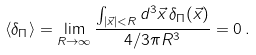Convert formula to latex. <formula><loc_0><loc_0><loc_500><loc_500>\langle \delta _ { \Pi } \rangle = \lim _ { R \rightarrow \infty } \frac { \int _ { | \vec { x } | < R } d ^ { 3 } \vec { x } \, \delta _ { \Pi } ( \vec { x } ) } { 4 / 3 \pi R ^ { 3 } } = 0 \, .</formula> 